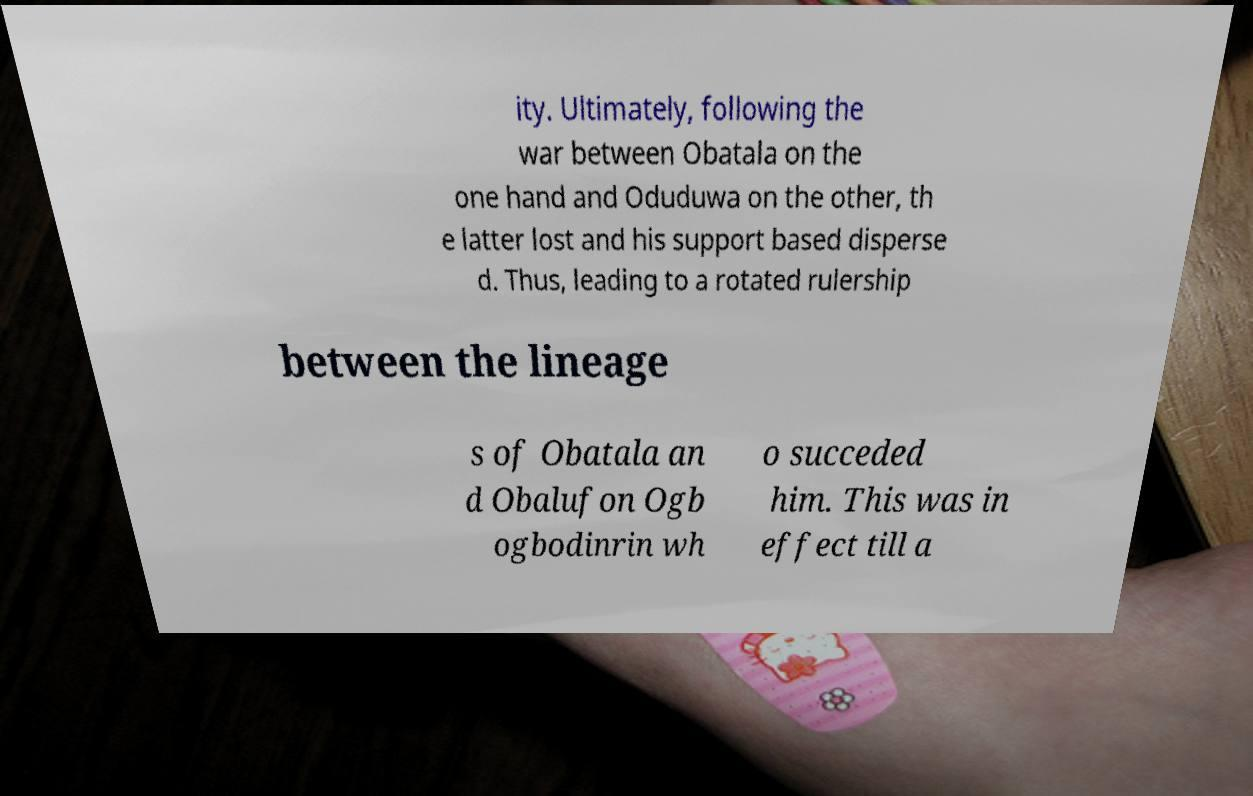Can you read and provide the text displayed in the image?This photo seems to have some interesting text. Can you extract and type it out for me? ity. Ultimately, following the war between Obatala on the one hand and Oduduwa on the other, th e latter lost and his support based disperse d. Thus, leading to a rotated rulership between the lineage s of Obatala an d Obalufon Ogb ogbodinrin wh o succeded him. This was in effect till a 